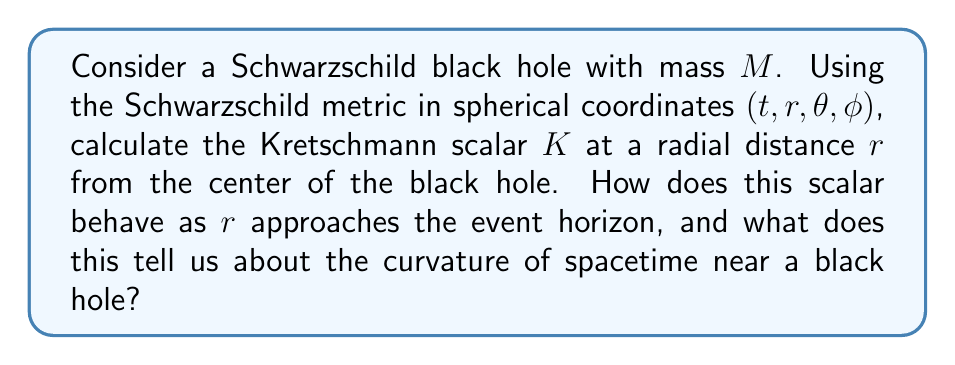Could you help me with this problem? To solve this problem, we'll follow these steps:

1) Recall the Schwarzschild metric:

   $$ds^2 = -\left(1-\frac{2GM}{c^2r}\right)c^2dt^2 + \left(1-\frac{2GM}{c^2r}\right)^{-1}dr^2 + r^2(d\theta^2 + \sin^2\theta d\phi^2)$$

2) The Kretschmann scalar $K$ is defined as:

   $$K = R_{\alpha\beta\gamma\delta}R^{\alpha\beta\gamma\delta}$$

   where $R_{\alpha\beta\gamma\delta}$ is the Riemann curvature tensor.

3) For the Schwarzschild metric, the Kretschmann scalar can be calculated to be:

   $$K = \frac{48G^2M^2}{c^4r^6}$$

4) To analyze the behavior near the event horizon, recall that the Schwarzschild radius (event horizon) is at $r_s = \frac{2GM}{c^2}$.

5) As $r$ approaches $r_s$, we can see that $K$ increases rapidly:

   $$\lim_{r \to r_s} K = \lim_{r \to r_s} \frac{48G^2M^2}{c^4r^6} = \frac{48G^2M^2}{c^4r_s^6} = \frac{3}{4G^2M^4}c^8$$

6) This finite but large value indicates a strong but not infinite curvature at the event horizon.

7) As $r$ approaches 0 (the singularity), $K$ diverges to infinity:

   $$\lim_{r \to 0} K = \lim_{r \to 0} \frac{48G^2M^2}{c^4r^6} = \infty$$

This behavior of the Kretschmann scalar tells us that the curvature of spacetime becomes extremely strong near a black hole, particularly as we approach the singularity. The finite value at the event horizon indicates that it is not a physical singularity, but rather a coordinate singularity. The true physical singularity exists at $r=0$, where the curvature becomes infinite.
Answer: The Kretschmann scalar for a Schwarzschild black hole is $K = \frac{48G^2M^2}{c^4r^6}$. As $r$ approaches the event horizon, $K$ approaches a large but finite value, indicating strong but not infinite curvature. As $r$ approaches 0, $K$ diverges to infinity, signifying a true physical singularity with infinite curvature. 